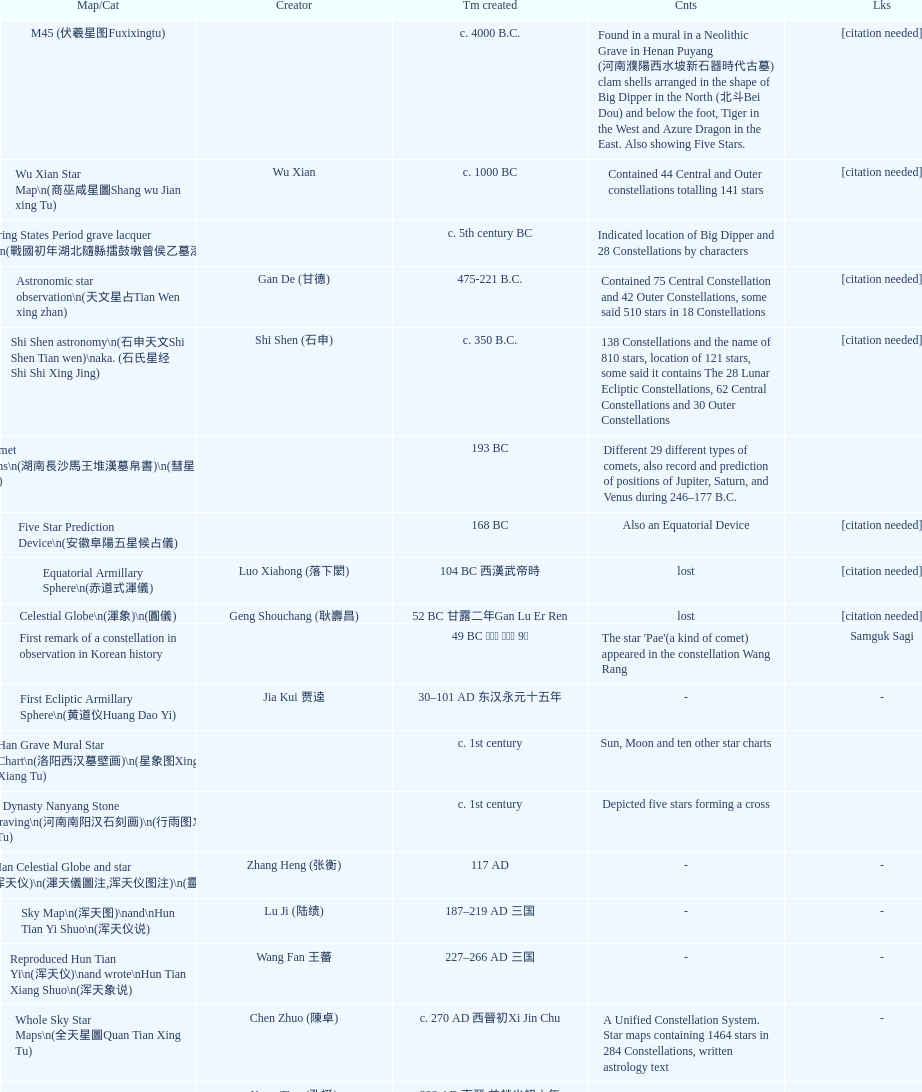What is the time gap between the creation dates of the five-star prediction device and the han comet diagrams? 25 years. 